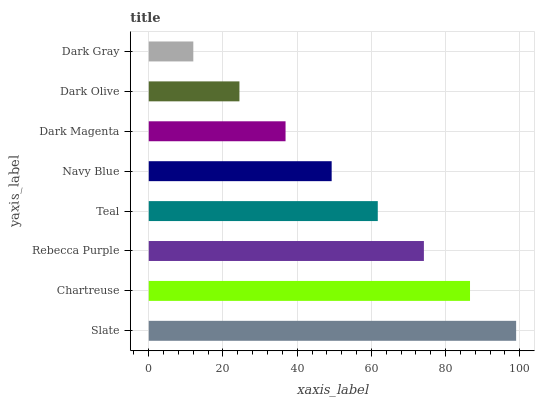Is Dark Gray the minimum?
Answer yes or no. Yes. Is Slate the maximum?
Answer yes or no. Yes. Is Chartreuse the minimum?
Answer yes or no. No. Is Chartreuse the maximum?
Answer yes or no. No. Is Slate greater than Chartreuse?
Answer yes or no. Yes. Is Chartreuse less than Slate?
Answer yes or no. Yes. Is Chartreuse greater than Slate?
Answer yes or no. No. Is Slate less than Chartreuse?
Answer yes or no. No. Is Teal the high median?
Answer yes or no. Yes. Is Navy Blue the low median?
Answer yes or no. Yes. Is Rebecca Purple the high median?
Answer yes or no. No. Is Dark Magenta the low median?
Answer yes or no. No. 